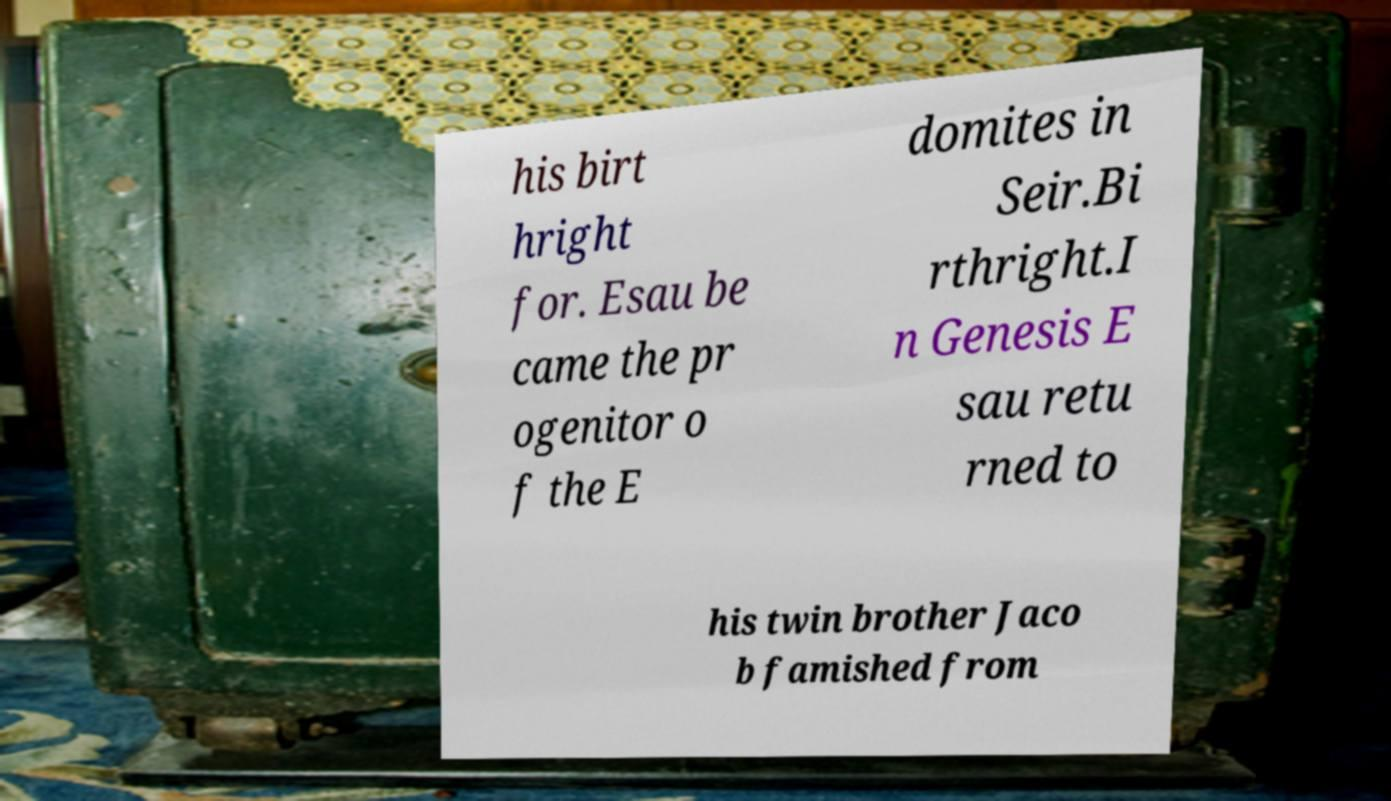What messages or text are displayed in this image? I need them in a readable, typed format. his birt hright for. Esau be came the pr ogenitor o f the E domites in Seir.Bi rthright.I n Genesis E sau retu rned to his twin brother Jaco b famished from 